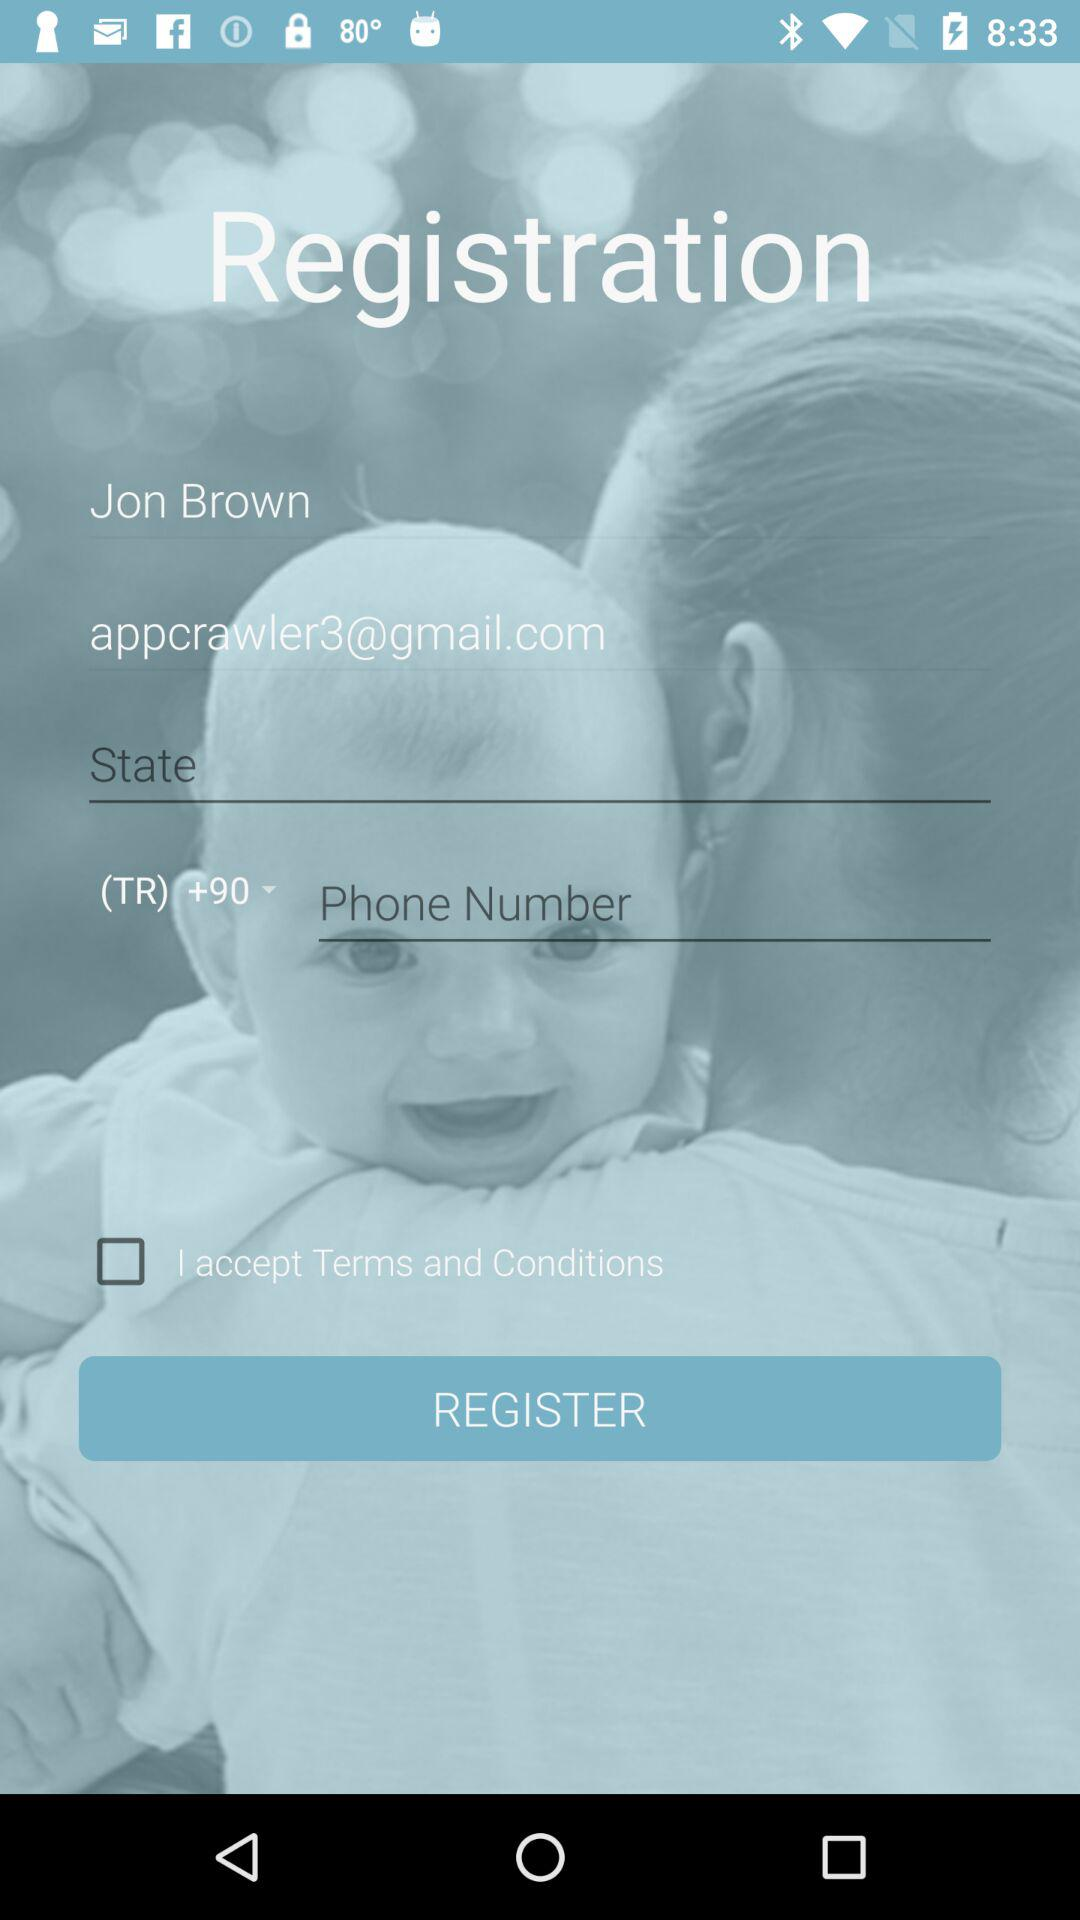What's the status of "I accept Terms and Conditions"? The status is "off". 